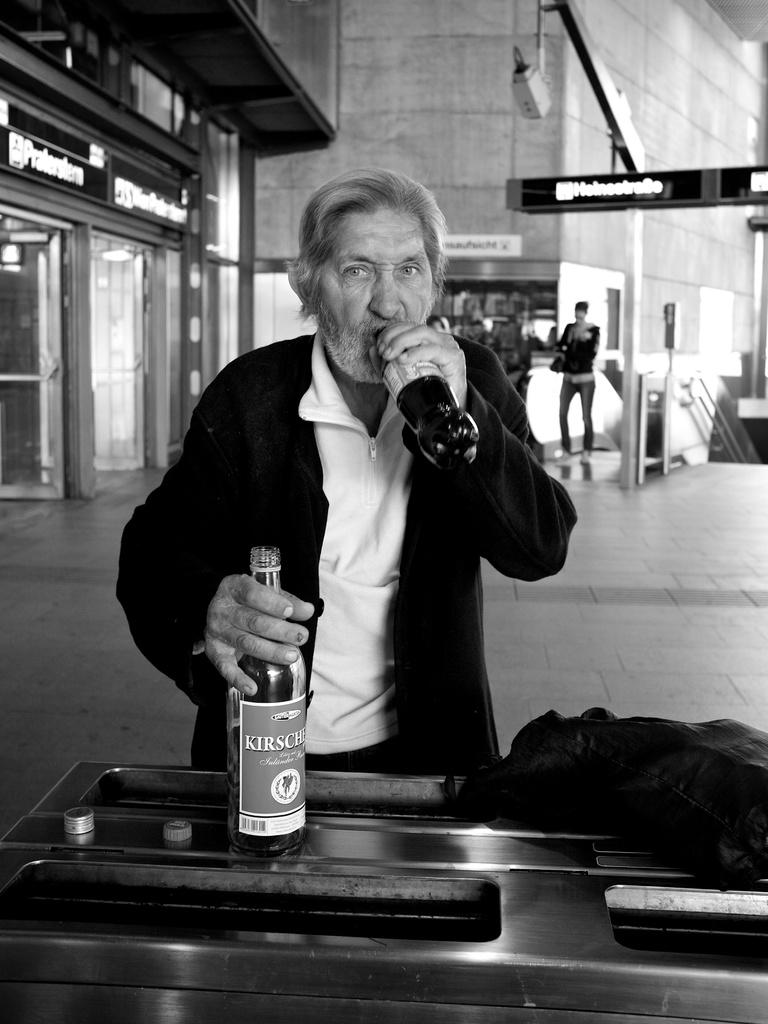Who is present in the image? There is a man in the image. What is the man doing in the image? The man is drinking a drink and holding a wine bottle in his hands. Where is the man located in relation to other objects or structures? The man is near a table. What can be seen in the background of the image? There are people standing in the background of the image and a wall. What type of disease is the man suffering from in the image? There is no indication in the image that the man is suffering from any disease. What scene is depicted in the image? The image does not depict a specific scene; it simply shows a man drinking a drink and holding a wine bottle near a table. 